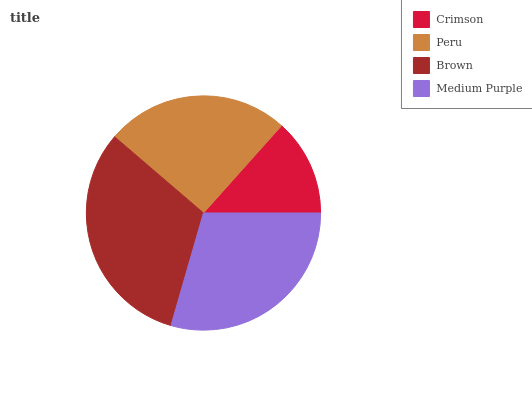Is Crimson the minimum?
Answer yes or no. Yes. Is Brown the maximum?
Answer yes or no. Yes. Is Peru the minimum?
Answer yes or no. No. Is Peru the maximum?
Answer yes or no. No. Is Peru greater than Crimson?
Answer yes or no. Yes. Is Crimson less than Peru?
Answer yes or no. Yes. Is Crimson greater than Peru?
Answer yes or no. No. Is Peru less than Crimson?
Answer yes or no. No. Is Medium Purple the high median?
Answer yes or no. Yes. Is Peru the low median?
Answer yes or no. Yes. Is Peru the high median?
Answer yes or no. No. Is Brown the low median?
Answer yes or no. No. 